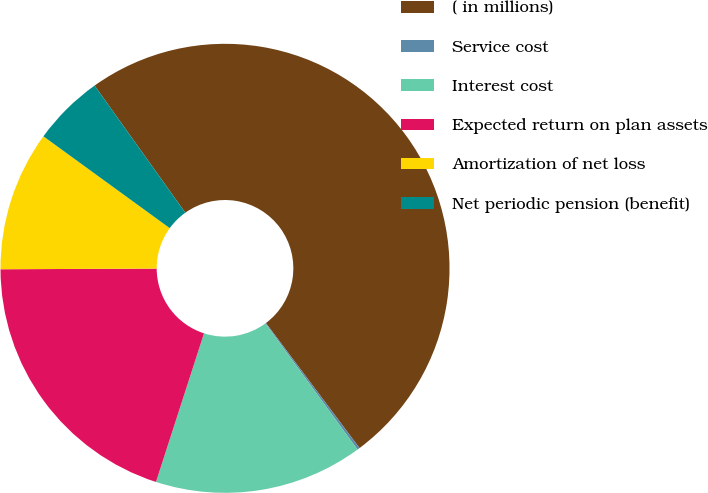<chart> <loc_0><loc_0><loc_500><loc_500><pie_chart><fcel>( in millions)<fcel>Service cost<fcel>Interest cost<fcel>Expected return on plan assets<fcel>Amortization of net loss<fcel>Net periodic pension (benefit)<nl><fcel>49.64%<fcel>0.18%<fcel>15.02%<fcel>19.96%<fcel>10.07%<fcel>5.13%<nl></chart> 